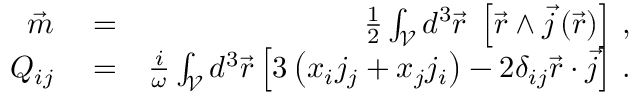Convert formula to latex. <formula><loc_0><loc_0><loc_500><loc_500>\begin{array} { r l r } { \vec { m } } & = } & { \frac { 1 } { 2 } \int _ { \mathcal { V } } d ^ { 3 } \vec { r } \, \left [ \vec { r } \wedge \vec { j } \left ( \vec { r } \right ) \right ] \, , } \\ { Q _ { i j } } & = } & { \frac { i } { \omega } \int _ { \mathcal { V } } d ^ { 3 } \vec { r } \left [ 3 \left ( x _ { i } j _ { j } + x _ { j } j _ { i } \right ) - 2 \delta _ { i j } \vec { r } \cdot \vec { j } \right ] \, . } \end{array}</formula> 